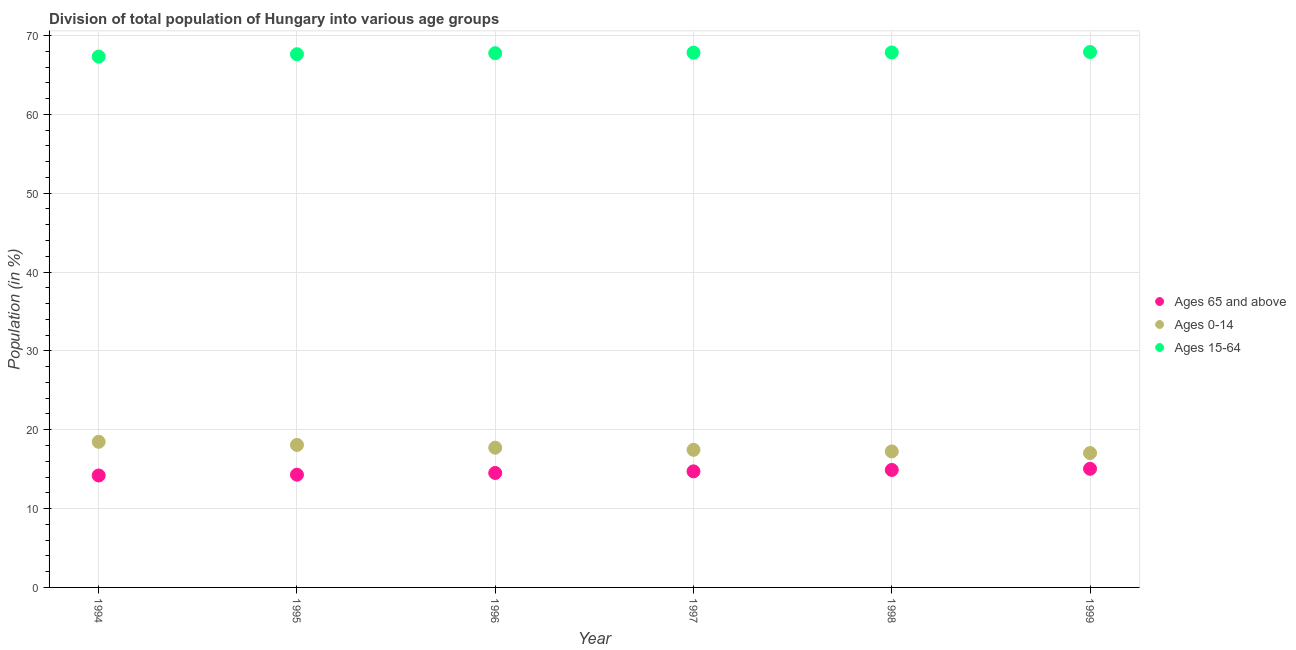How many different coloured dotlines are there?
Provide a short and direct response. 3. Is the number of dotlines equal to the number of legend labels?
Ensure brevity in your answer.  Yes. What is the percentage of population within the age-group 0-14 in 1999?
Your answer should be compact. 17.04. Across all years, what is the maximum percentage of population within the age-group of 65 and above?
Ensure brevity in your answer.  15.05. Across all years, what is the minimum percentage of population within the age-group of 65 and above?
Offer a terse response. 14.2. In which year was the percentage of population within the age-group 15-64 minimum?
Give a very brief answer. 1994. What is the total percentage of population within the age-group 0-14 in the graph?
Offer a terse response. 106.01. What is the difference between the percentage of population within the age-group of 65 and above in 1998 and that in 1999?
Offer a terse response. -0.14. What is the difference between the percentage of population within the age-group 0-14 in 1997 and the percentage of population within the age-group 15-64 in 1996?
Offer a very short reply. -50.31. What is the average percentage of population within the age-group of 65 and above per year?
Provide a succinct answer. 14.61. In the year 1997, what is the difference between the percentage of population within the age-group of 65 and above and percentage of population within the age-group 0-14?
Your response must be concise. -2.73. What is the ratio of the percentage of population within the age-group 0-14 in 1995 to that in 1997?
Your response must be concise. 1.04. Is the difference between the percentage of population within the age-group of 65 and above in 1997 and 1999 greater than the difference between the percentage of population within the age-group 15-64 in 1997 and 1999?
Provide a succinct answer. No. What is the difference between the highest and the second highest percentage of population within the age-group 0-14?
Make the answer very short. 0.4. What is the difference between the highest and the lowest percentage of population within the age-group of 65 and above?
Give a very brief answer. 0.85. In how many years, is the percentage of population within the age-group 15-64 greater than the average percentage of population within the age-group 15-64 taken over all years?
Make the answer very short. 4. Is the sum of the percentage of population within the age-group 15-64 in 1997 and 1998 greater than the maximum percentage of population within the age-group 0-14 across all years?
Give a very brief answer. Yes. Is it the case that in every year, the sum of the percentage of population within the age-group of 65 and above and percentage of population within the age-group 0-14 is greater than the percentage of population within the age-group 15-64?
Your response must be concise. No. Does the percentage of population within the age-group 15-64 monotonically increase over the years?
Offer a terse response. Yes. Is the percentage of population within the age-group of 65 and above strictly greater than the percentage of population within the age-group 15-64 over the years?
Provide a short and direct response. No. Is the percentage of population within the age-group 15-64 strictly less than the percentage of population within the age-group of 65 and above over the years?
Keep it short and to the point. No. How many years are there in the graph?
Give a very brief answer. 6. What is the difference between two consecutive major ticks on the Y-axis?
Keep it short and to the point. 10. Are the values on the major ticks of Y-axis written in scientific E-notation?
Make the answer very short. No. Does the graph contain grids?
Offer a terse response. Yes. Where does the legend appear in the graph?
Give a very brief answer. Center right. What is the title of the graph?
Provide a short and direct response. Division of total population of Hungary into various age groups
. Does "Ages 15-20" appear as one of the legend labels in the graph?
Make the answer very short. No. What is the label or title of the X-axis?
Give a very brief answer. Year. What is the Population (in %) of Ages 65 and above in 1994?
Make the answer very short. 14.2. What is the Population (in %) in Ages 0-14 in 1994?
Offer a terse response. 18.47. What is the Population (in %) of Ages 15-64 in 1994?
Keep it short and to the point. 67.33. What is the Population (in %) of Ages 65 and above in 1995?
Offer a terse response. 14.3. What is the Population (in %) of Ages 0-14 in 1995?
Offer a terse response. 18.07. What is the Population (in %) in Ages 15-64 in 1995?
Your response must be concise. 67.63. What is the Population (in %) of Ages 65 and above in 1996?
Make the answer very short. 14.52. What is the Population (in %) of Ages 0-14 in 1996?
Make the answer very short. 17.72. What is the Population (in %) of Ages 15-64 in 1996?
Your answer should be compact. 67.76. What is the Population (in %) in Ages 65 and above in 1997?
Your response must be concise. 14.72. What is the Population (in %) in Ages 0-14 in 1997?
Keep it short and to the point. 17.45. What is the Population (in %) in Ages 15-64 in 1997?
Offer a very short reply. 67.83. What is the Population (in %) of Ages 65 and above in 1998?
Ensure brevity in your answer.  14.9. What is the Population (in %) in Ages 0-14 in 1998?
Your response must be concise. 17.25. What is the Population (in %) in Ages 15-64 in 1998?
Offer a very short reply. 67.85. What is the Population (in %) of Ages 65 and above in 1999?
Make the answer very short. 15.05. What is the Population (in %) of Ages 0-14 in 1999?
Provide a succinct answer. 17.04. What is the Population (in %) in Ages 15-64 in 1999?
Provide a short and direct response. 67.91. Across all years, what is the maximum Population (in %) of Ages 65 and above?
Your answer should be very brief. 15.05. Across all years, what is the maximum Population (in %) of Ages 0-14?
Give a very brief answer. 18.47. Across all years, what is the maximum Population (in %) in Ages 15-64?
Provide a short and direct response. 67.91. Across all years, what is the minimum Population (in %) of Ages 65 and above?
Offer a very short reply. 14.2. Across all years, what is the minimum Population (in %) in Ages 0-14?
Make the answer very short. 17.04. Across all years, what is the minimum Population (in %) of Ages 15-64?
Offer a terse response. 67.33. What is the total Population (in %) of Ages 65 and above in the graph?
Offer a very short reply. 87.68. What is the total Population (in %) of Ages 0-14 in the graph?
Keep it short and to the point. 106.01. What is the total Population (in %) of Ages 15-64 in the graph?
Provide a succinct answer. 406.31. What is the difference between the Population (in %) of Ages 65 and above in 1994 and that in 1995?
Ensure brevity in your answer.  -0.1. What is the difference between the Population (in %) in Ages 0-14 in 1994 and that in 1995?
Provide a short and direct response. 0.4. What is the difference between the Population (in %) in Ages 15-64 in 1994 and that in 1995?
Your response must be concise. -0.3. What is the difference between the Population (in %) of Ages 65 and above in 1994 and that in 1996?
Provide a succinct answer. -0.32. What is the difference between the Population (in %) of Ages 0-14 in 1994 and that in 1996?
Make the answer very short. 0.75. What is the difference between the Population (in %) of Ages 15-64 in 1994 and that in 1996?
Ensure brevity in your answer.  -0.43. What is the difference between the Population (in %) of Ages 65 and above in 1994 and that in 1997?
Give a very brief answer. -0.52. What is the difference between the Population (in %) in Ages 0-14 in 1994 and that in 1997?
Keep it short and to the point. 1.02. What is the difference between the Population (in %) in Ages 15-64 in 1994 and that in 1997?
Your answer should be compact. -0.5. What is the difference between the Population (in %) of Ages 65 and above in 1994 and that in 1998?
Your response must be concise. -0.7. What is the difference between the Population (in %) of Ages 0-14 in 1994 and that in 1998?
Your response must be concise. 1.22. What is the difference between the Population (in %) of Ages 15-64 in 1994 and that in 1998?
Your answer should be very brief. -0.52. What is the difference between the Population (in %) of Ages 65 and above in 1994 and that in 1999?
Your answer should be compact. -0.85. What is the difference between the Population (in %) of Ages 0-14 in 1994 and that in 1999?
Ensure brevity in your answer.  1.43. What is the difference between the Population (in %) of Ages 15-64 in 1994 and that in 1999?
Offer a very short reply. -0.58. What is the difference between the Population (in %) in Ages 65 and above in 1995 and that in 1996?
Ensure brevity in your answer.  -0.22. What is the difference between the Population (in %) in Ages 0-14 in 1995 and that in 1996?
Provide a succinct answer. 0.35. What is the difference between the Population (in %) in Ages 15-64 in 1995 and that in 1996?
Your response must be concise. -0.13. What is the difference between the Population (in %) in Ages 65 and above in 1995 and that in 1997?
Give a very brief answer. -0.42. What is the difference between the Population (in %) of Ages 0-14 in 1995 and that in 1997?
Give a very brief answer. 0.62. What is the difference between the Population (in %) of Ages 15-64 in 1995 and that in 1997?
Your answer should be compact. -0.2. What is the difference between the Population (in %) of Ages 65 and above in 1995 and that in 1998?
Offer a very short reply. -0.6. What is the difference between the Population (in %) in Ages 0-14 in 1995 and that in 1998?
Your answer should be compact. 0.83. What is the difference between the Population (in %) in Ages 15-64 in 1995 and that in 1998?
Make the answer very short. -0.22. What is the difference between the Population (in %) in Ages 65 and above in 1995 and that in 1999?
Offer a very short reply. -0.75. What is the difference between the Population (in %) of Ages 0-14 in 1995 and that in 1999?
Offer a terse response. 1.03. What is the difference between the Population (in %) of Ages 15-64 in 1995 and that in 1999?
Ensure brevity in your answer.  -0.28. What is the difference between the Population (in %) of Ages 65 and above in 1996 and that in 1997?
Your answer should be compact. -0.2. What is the difference between the Population (in %) in Ages 0-14 in 1996 and that in 1997?
Offer a very short reply. 0.27. What is the difference between the Population (in %) in Ages 15-64 in 1996 and that in 1997?
Provide a short and direct response. -0.06. What is the difference between the Population (in %) of Ages 65 and above in 1996 and that in 1998?
Provide a succinct answer. -0.38. What is the difference between the Population (in %) of Ages 0-14 in 1996 and that in 1998?
Keep it short and to the point. 0.47. What is the difference between the Population (in %) of Ages 15-64 in 1996 and that in 1998?
Your answer should be very brief. -0.09. What is the difference between the Population (in %) of Ages 65 and above in 1996 and that in 1999?
Your answer should be compact. -0.53. What is the difference between the Population (in %) in Ages 0-14 in 1996 and that in 1999?
Ensure brevity in your answer.  0.68. What is the difference between the Population (in %) of Ages 15-64 in 1996 and that in 1999?
Give a very brief answer. -0.15. What is the difference between the Population (in %) in Ages 65 and above in 1997 and that in 1998?
Provide a succinct answer. -0.18. What is the difference between the Population (in %) in Ages 0-14 in 1997 and that in 1998?
Give a very brief answer. 0.21. What is the difference between the Population (in %) in Ages 15-64 in 1997 and that in 1998?
Your response must be concise. -0.03. What is the difference between the Population (in %) of Ages 65 and above in 1997 and that in 1999?
Ensure brevity in your answer.  -0.32. What is the difference between the Population (in %) in Ages 0-14 in 1997 and that in 1999?
Offer a terse response. 0.41. What is the difference between the Population (in %) in Ages 15-64 in 1997 and that in 1999?
Your response must be concise. -0.08. What is the difference between the Population (in %) in Ages 65 and above in 1998 and that in 1999?
Keep it short and to the point. -0.14. What is the difference between the Population (in %) in Ages 0-14 in 1998 and that in 1999?
Provide a succinct answer. 0.2. What is the difference between the Population (in %) in Ages 15-64 in 1998 and that in 1999?
Offer a very short reply. -0.06. What is the difference between the Population (in %) in Ages 65 and above in 1994 and the Population (in %) in Ages 0-14 in 1995?
Offer a very short reply. -3.87. What is the difference between the Population (in %) of Ages 65 and above in 1994 and the Population (in %) of Ages 15-64 in 1995?
Keep it short and to the point. -53.43. What is the difference between the Population (in %) of Ages 0-14 in 1994 and the Population (in %) of Ages 15-64 in 1995?
Keep it short and to the point. -49.16. What is the difference between the Population (in %) in Ages 65 and above in 1994 and the Population (in %) in Ages 0-14 in 1996?
Keep it short and to the point. -3.52. What is the difference between the Population (in %) in Ages 65 and above in 1994 and the Population (in %) in Ages 15-64 in 1996?
Provide a short and direct response. -53.56. What is the difference between the Population (in %) of Ages 0-14 in 1994 and the Population (in %) of Ages 15-64 in 1996?
Your answer should be very brief. -49.29. What is the difference between the Population (in %) in Ages 65 and above in 1994 and the Population (in %) in Ages 0-14 in 1997?
Make the answer very short. -3.25. What is the difference between the Population (in %) of Ages 65 and above in 1994 and the Population (in %) of Ages 15-64 in 1997?
Make the answer very short. -53.63. What is the difference between the Population (in %) in Ages 0-14 in 1994 and the Population (in %) in Ages 15-64 in 1997?
Offer a terse response. -49.36. What is the difference between the Population (in %) of Ages 65 and above in 1994 and the Population (in %) of Ages 0-14 in 1998?
Offer a terse response. -3.05. What is the difference between the Population (in %) of Ages 65 and above in 1994 and the Population (in %) of Ages 15-64 in 1998?
Your answer should be compact. -53.65. What is the difference between the Population (in %) in Ages 0-14 in 1994 and the Population (in %) in Ages 15-64 in 1998?
Your answer should be very brief. -49.38. What is the difference between the Population (in %) in Ages 65 and above in 1994 and the Population (in %) in Ages 0-14 in 1999?
Give a very brief answer. -2.84. What is the difference between the Population (in %) of Ages 65 and above in 1994 and the Population (in %) of Ages 15-64 in 1999?
Make the answer very short. -53.71. What is the difference between the Population (in %) in Ages 0-14 in 1994 and the Population (in %) in Ages 15-64 in 1999?
Keep it short and to the point. -49.44. What is the difference between the Population (in %) in Ages 65 and above in 1995 and the Population (in %) in Ages 0-14 in 1996?
Your answer should be very brief. -3.42. What is the difference between the Population (in %) of Ages 65 and above in 1995 and the Population (in %) of Ages 15-64 in 1996?
Provide a short and direct response. -53.46. What is the difference between the Population (in %) of Ages 0-14 in 1995 and the Population (in %) of Ages 15-64 in 1996?
Offer a very short reply. -49.69. What is the difference between the Population (in %) of Ages 65 and above in 1995 and the Population (in %) of Ages 0-14 in 1997?
Make the answer very short. -3.15. What is the difference between the Population (in %) in Ages 65 and above in 1995 and the Population (in %) in Ages 15-64 in 1997?
Offer a very short reply. -53.53. What is the difference between the Population (in %) of Ages 0-14 in 1995 and the Population (in %) of Ages 15-64 in 1997?
Make the answer very short. -49.75. What is the difference between the Population (in %) in Ages 65 and above in 1995 and the Population (in %) in Ages 0-14 in 1998?
Your answer should be very brief. -2.95. What is the difference between the Population (in %) of Ages 65 and above in 1995 and the Population (in %) of Ages 15-64 in 1998?
Provide a succinct answer. -53.55. What is the difference between the Population (in %) in Ages 0-14 in 1995 and the Population (in %) in Ages 15-64 in 1998?
Make the answer very short. -49.78. What is the difference between the Population (in %) in Ages 65 and above in 1995 and the Population (in %) in Ages 0-14 in 1999?
Give a very brief answer. -2.74. What is the difference between the Population (in %) in Ages 65 and above in 1995 and the Population (in %) in Ages 15-64 in 1999?
Ensure brevity in your answer.  -53.61. What is the difference between the Population (in %) of Ages 0-14 in 1995 and the Population (in %) of Ages 15-64 in 1999?
Give a very brief answer. -49.84. What is the difference between the Population (in %) of Ages 65 and above in 1996 and the Population (in %) of Ages 0-14 in 1997?
Keep it short and to the point. -2.94. What is the difference between the Population (in %) in Ages 65 and above in 1996 and the Population (in %) in Ages 15-64 in 1997?
Give a very brief answer. -53.31. What is the difference between the Population (in %) of Ages 0-14 in 1996 and the Population (in %) of Ages 15-64 in 1997?
Make the answer very short. -50.1. What is the difference between the Population (in %) in Ages 65 and above in 1996 and the Population (in %) in Ages 0-14 in 1998?
Offer a terse response. -2.73. What is the difference between the Population (in %) in Ages 65 and above in 1996 and the Population (in %) in Ages 15-64 in 1998?
Offer a terse response. -53.33. What is the difference between the Population (in %) of Ages 0-14 in 1996 and the Population (in %) of Ages 15-64 in 1998?
Your answer should be compact. -50.13. What is the difference between the Population (in %) of Ages 65 and above in 1996 and the Population (in %) of Ages 0-14 in 1999?
Provide a short and direct response. -2.53. What is the difference between the Population (in %) in Ages 65 and above in 1996 and the Population (in %) in Ages 15-64 in 1999?
Provide a succinct answer. -53.39. What is the difference between the Population (in %) of Ages 0-14 in 1996 and the Population (in %) of Ages 15-64 in 1999?
Your answer should be compact. -50.19. What is the difference between the Population (in %) in Ages 65 and above in 1997 and the Population (in %) in Ages 0-14 in 1998?
Your response must be concise. -2.53. What is the difference between the Population (in %) of Ages 65 and above in 1997 and the Population (in %) of Ages 15-64 in 1998?
Your answer should be very brief. -53.13. What is the difference between the Population (in %) in Ages 0-14 in 1997 and the Population (in %) in Ages 15-64 in 1998?
Make the answer very short. -50.4. What is the difference between the Population (in %) in Ages 65 and above in 1997 and the Population (in %) in Ages 0-14 in 1999?
Your answer should be very brief. -2.32. What is the difference between the Population (in %) of Ages 65 and above in 1997 and the Population (in %) of Ages 15-64 in 1999?
Keep it short and to the point. -53.19. What is the difference between the Population (in %) of Ages 0-14 in 1997 and the Population (in %) of Ages 15-64 in 1999?
Ensure brevity in your answer.  -50.46. What is the difference between the Population (in %) of Ages 65 and above in 1998 and the Population (in %) of Ages 0-14 in 1999?
Provide a succinct answer. -2.14. What is the difference between the Population (in %) of Ages 65 and above in 1998 and the Population (in %) of Ages 15-64 in 1999?
Give a very brief answer. -53.01. What is the difference between the Population (in %) of Ages 0-14 in 1998 and the Population (in %) of Ages 15-64 in 1999?
Keep it short and to the point. -50.66. What is the average Population (in %) in Ages 65 and above per year?
Offer a terse response. 14.61. What is the average Population (in %) in Ages 0-14 per year?
Offer a very short reply. 17.67. What is the average Population (in %) of Ages 15-64 per year?
Provide a succinct answer. 67.72. In the year 1994, what is the difference between the Population (in %) in Ages 65 and above and Population (in %) in Ages 0-14?
Your response must be concise. -4.27. In the year 1994, what is the difference between the Population (in %) of Ages 65 and above and Population (in %) of Ages 15-64?
Your answer should be very brief. -53.13. In the year 1994, what is the difference between the Population (in %) in Ages 0-14 and Population (in %) in Ages 15-64?
Your response must be concise. -48.86. In the year 1995, what is the difference between the Population (in %) in Ages 65 and above and Population (in %) in Ages 0-14?
Give a very brief answer. -3.77. In the year 1995, what is the difference between the Population (in %) in Ages 65 and above and Population (in %) in Ages 15-64?
Offer a terse response. -53.33. In the year 1995, what is the difference between the Population (in %) of Ages 0-14 and Population (in %) of Ages 15-64?
Give a very brief answer. -49.55. In the year 1996, what is the difference between the Population (in %) in Ages 65 and above and Population (in %) in Ages 0-14?
Provide a succinct answer. -3.2. In the year 1996, what is the difference between the Population (in %) in Ages 65 and above and Population (in %) in Ages 15-64?
Ensure brevity in your answer.  -53.24. In the year 1996, what is the difference between the Population (in %) in Ages 0-14 and Population (in %) in Ages 15-64?
Your response must be concise. -50.04. In the year 1997, what is the difference between the Population (in %) in Ages 65 and above and Population (in %) in Ages 0-14?
Your answer should be compact. -2.73. In the year 1997, what is the difference between the Population (in %) in Ages 65 and above and Population (in %) in Ages 15-64?
Provide a short and direct response. -53.1. In the year 1997, what is the difference between the Population (in %) of Ages 0-14 and Population (in %) of Ages 15-64?
Offer a terse response. -50.37. In the year 1998, what is the difference between the Population (in %) in Ages 65 and above and Population (in %) in Ages 0-14?
Make the answer very short. -2.35. In the year 1998, what is the difference between the Population (in %) in Ages 65 and above and Population (in %) in Ages 15-64?
Make the answer very short. -52.95. In the year 1998, what is the difference between the Population (in %) of Ages 0-14 and Population (in %) of Ages 15-64?
Keep it short and to the point. -50.6. In the year 1999, what is the difference between the Population (in %) of Ages 65 and above and Population (in %) of Ages 0-14?
Provide a short and direct response. -2. In the year 1999, what is the difference between the Population (in %) in Ages 65 and above and Population (in %) in Ages 15-64?
Give a very brief answer. -52.86. In the year 1999, what is the difference between the Population (in %) of Ages 0-14 and Population (in %) of Ages 15-64?
Your response must be concise. -50.87. What is the ratio of the Population (in %) in Ages 65 and above in 1994 to that in 1995?
Keep it short and to the point. 0.99. What is the ratio of the Population (in %) of Ages 0-14 in 1994 to that in 1995?
Your answer should be very brief. 1.02. What is the ratio of the Population (in %) of Ages 65 and above in 1994 to that in 1996?
Provide a succinct answer. 0.98. What is the ratio of the Population (in %) in Ages 0-14 in 1994 to that in 1996?
Ensure brevity in your answer.  1.04. What is the ratio of the Population (in %) of Ages 65 and above in 1994 to that in 1997?
Give a very brief answer. 0.96. What is the ratio of the Population (in %) of Ages 0-14 in 1994 to that in 1997?
Your response must be concise. 1.06. What is the ratio of the Population (in %) of Ages 15-64 in 1994 to that in 1997?
Your answer should be very brief. 0.99. What is the ratio of the Population (in %) of Ages 65 and above in 1994 to that in 1998?
Your answer should be compact. 0.95. What is the ratio of the Population (in %) of Ages 0-14 in 1994 to that in 1998?
Make the answer very short. 1.07. What is the ratio of the Population (in %) in Ages 15-64 in 1994 to that in 1998?
Offer a terse response. 0.99. What is the ratio of the Population (in %) of Ages 65 and above in 1994 to that in 1999?
Your answer should be very brief. 0.94. What is the ratio of the Population (in %) in Ages 0-14 in 1994 to that in 1999?
Provide a short and direct response. 1.08. What is the ratio of the Population (in %) of Ages 65 and above in 1995 to that in 1996?
Your answer should be compact. 0.98. What is the ratio of the Population (in %) of Ages 0-14 in 1995 to that in 1996?
Your answer should be compact. 1.02. What is the ratio of the Population (in %) in Ages 15-64 in 1995 to that in 1996?
Your response must be concise. 1. What is the ratio of the Population (in %) of Ages 65 and above in 1995 to that in 1997?
Provide a succinct answer. 0.97. What is the ratio of the Population (in %) in Ages 0-14 in 1995 to that in 1997?
Offer a very short reply. 1.04. What is the ratio of the Population (in %) in Ages 15-64 in 1995 to that in 1997?
Give a very brief answer. 1. What is the ratio of the Population (in %) in Ages 65 and above in 1995 to that in 1998?
Your response must be concise. 0.96. What is the ratio of the Population (in %) of Ages 0-14 in 1995 to that in 1998?
Ensure brevity in your answer.  1.05. What is the ratio of the Population (in %) in Ages 15-64 in 1995 to that in 1998?
Keep it short and to the point. 1. What is the ratio of the Population (in %) of Ages 65 and above in 1995 to that in 1999?
Give a very brief answer. 0.95. What is the ratio of the Population (in %) in Ages 0-14 in 1995 to that in 1999?
Provide a short and direct response. 1.06. What is the ratio of the Population (in %) of Ages 65 and above in 1996 to that in 1997?
Offer a very short reply. 0.99. What is the ratio of the Population (in %) in Ages 0-14 in 1996 to that in 1997?
Offer a very short reply. 1.02. What is the ratio of the Population (in %) of Ages 15-64 in 1996 to that in 1997?
Your response must be concise. 1. What is the ratio of the Population (in %) in Ages 65 and above in 1996 to that in 1998?
Make the answer very short. 0.97. What is the ratio of the Population (in %) in Ages 0-14 in 1996 to that in 1998?
Offer a very short reply. 1.03. What is the ratio of the Population (in %) of Ages 65 and above in 1996 to that in 1999?
Ensure brevity in your answer.  0.96. What is the ratio of the Population (in %) of Ages 0-14 in 1996 to that in 1999?
Offer a terse response. 1.04. What is the ratio of the Population (in %) of Ages 15-64 in 1996 to that in 1999?
Provide a succinct answer. 1. What is the ratio of the Population (in %) of Ages 65 and above in 1997 to that in 1998?
Offer a very short reply. 0.99. What is the ratio of the Population (in %) in Ages 0-14 in 1997 to that in 1998?
Offer a very short reply. 1.01. What is the ratio of the Population (in %) in Ages 65 and above in 1997 to that in 1999?
Your answer should be very brief. 0.98. What is the ratio of the Population (in %) of Ages 15-64 in 1997 to that in 1999?
Provide a short and direct response. 1. What is the ratio of the Population (in %) of Ages 0-14 in 1998 to that in 1999?
Make the answer very short. 1.01. What is the difference between the highest and the second highest Population (in %) in Ages 65 and above?
Offer a terse response. 0.14. What is the difference between the highest and the second highest Population (in %) of Ages 0-14?
Make the answer very short. 0.4. What is the difference between the highest and the second highest Population (in %) of Ages 15-64?
Keep it short and to the point. 0.06. What is the difference between the highest and the lowest Population (in %) of Ages 65 and above?
Offer a terse response. 0.85. What is the difference between the highest and the lowest Population (in %) of Ages 0-14?
Ensure brevity in your answer.  1.43. What is the difference between the highest and the lowest Population (in %) in Ages 15-64?
Ensure brevity in your answer.  0.58. 